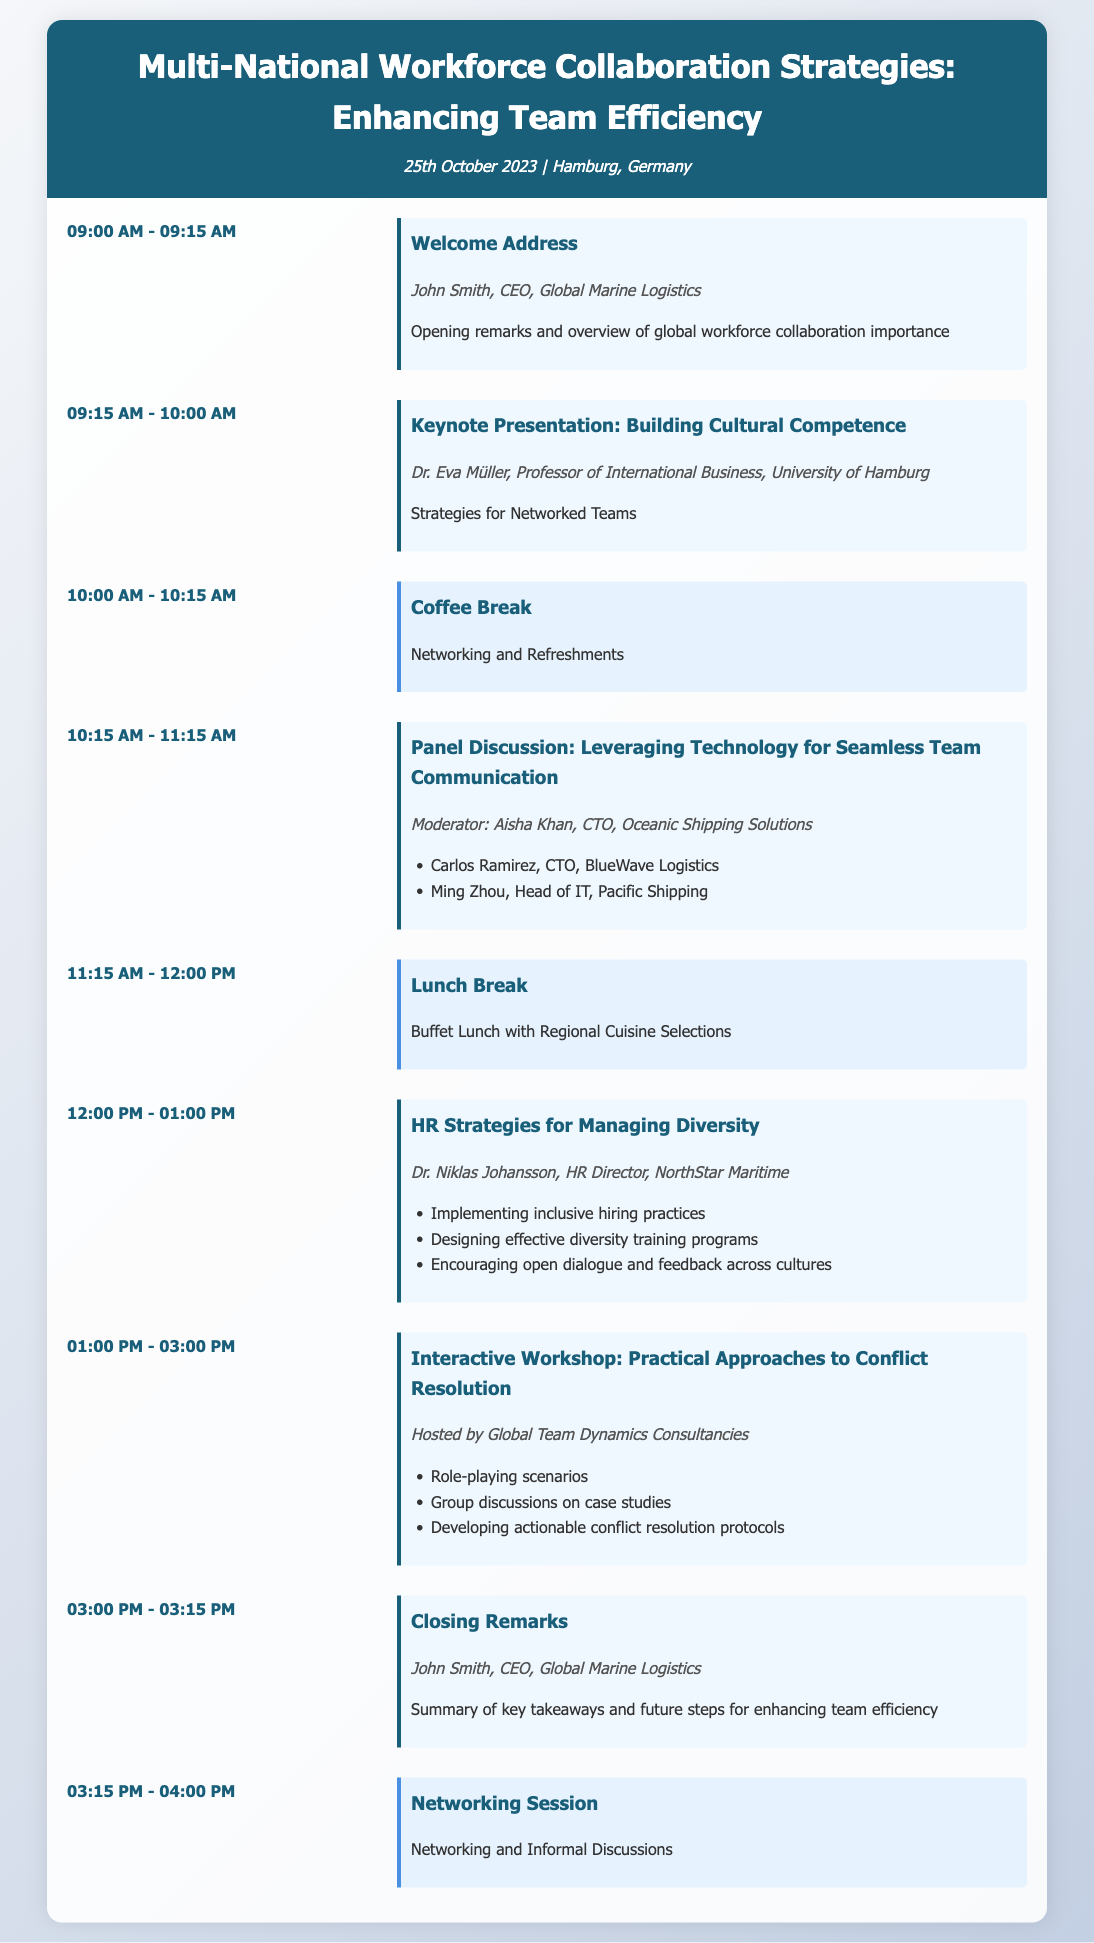What is the date of the event? The date of the event is mentioned in the header of the document.
Answer: 25th October 2023 Who is the speaker for the keynote presentation? The document provides the name and title of the speaker for each event.
Answer: Dr. Eva Müller What time does the interactive workshop start? The start time for each event is listed in the schedule.
Answer: 01:00 PM How long is the coffee break? The document indicates the duration of the coffee break in the timetable.
Answer: 15 minutes What is the main topic of the closing remarks? The topic of the closing remarks is described in the event description.
Answer: Summary of key takeaways Who moderates the panel discussion? The speaker list within the panel discussion specifies the moderator.
Answer: Aisha Khan What type of cuisine is offered during the lunch break? The description for the lunch break highlights the cuisine type.
Answer: Regional Cuisine Selections Which organization hosts the interactive workshop? The hosting organization for the workshop is mentioned in the event details.
Answer: Global Team Dynamics Consultancies What is the duration of the lunch break? The length of the lunch break is listed alongside the event.
Answer: 1 hour 